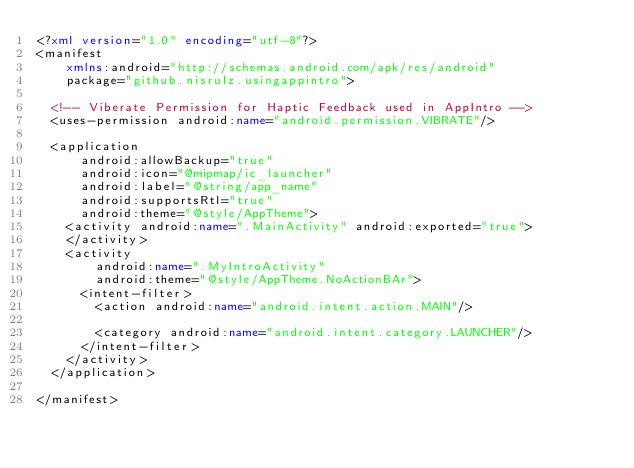Convert code to text. <code><loc_0><loc_0><loc_500><loc_500><_XML_><?xml version="1.0" encoding="utf-8"?>
<manifest
    xmlns:android="http://schemas.android.com/apk/res/android"
    package="github.nisrulz.usingappintro">

  <!-- Viberate Permission for Haptic Feedback used in AppIntro -->
  <uses-permission android:name="android.permission.VIBRATE"/>

  <application
      android:allowBackup="true"
      android:icon="@mipmap/ic_launcher"
      android:label="@string/app_name"
      android:supportsRtl="true"
      android:theme="@style/AppTheme">
    <activity android:name=".MainActivity" android:exported="true">
    </activity>
    <activity
        android:name=".MyIntroActivity"
        android:theme="@style/AppTheme.NoActionBAr">
      <intent-filter>
        <action android:name="android.intent.action.MAIN"/>

        <category android:name="android.intent.category.LAUNCHER"/>
      </intent-filter>
    </activity>
  </application>

</manifest>
</code> 